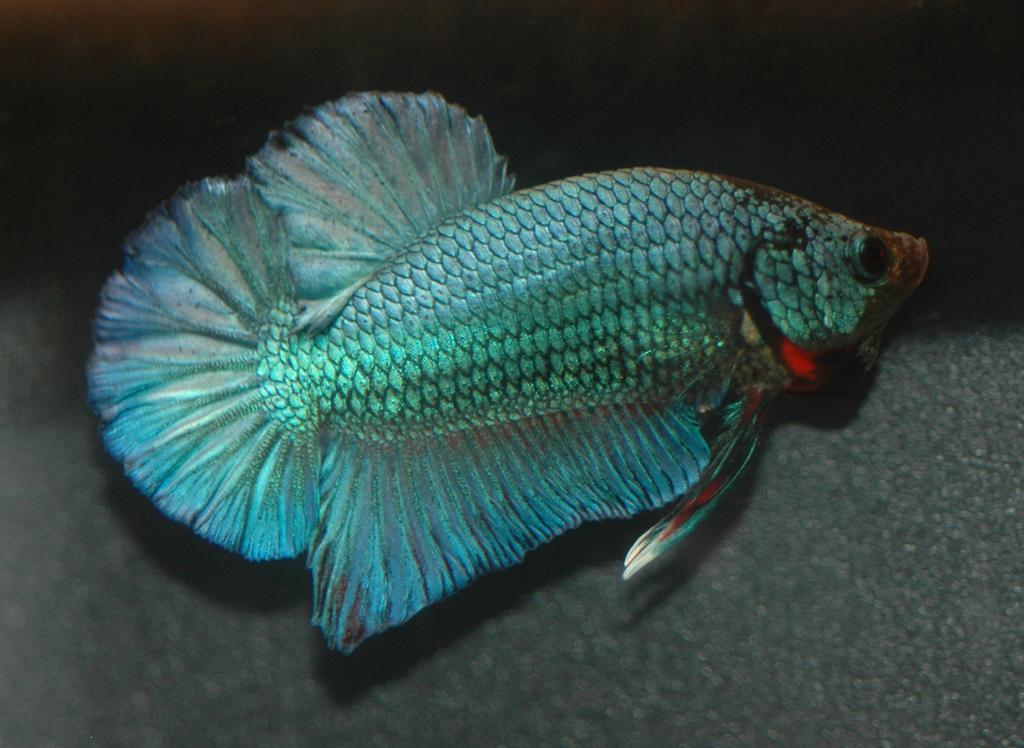What color is the fish in the image? The fish in the image is silver in color. What color is the bottom of the image? The bottom of the image is grey in color. What color is the background of the image? The background of the image is black in color. Where might the image have been taken? The image might have been taken in an aquarium. What type of scent can be detected from the fish in the image? There is no mention of a scent in the image, and it is not possible to detect a scent from a two-dimensional image. 